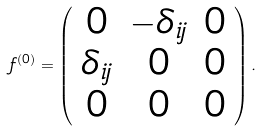Convert formula to latex. <formula><loc_0><loc_0><loc_500><loc_500>f ^ { ( 0 ) } = \left ( \begin{array} { c c c } { 0 } & { { - \delta _ { i j } } } & { 0 } \\ { { \delta _ { i j } } } & { 0 } & { 0 } \\ { 0 } & { 0 } & { 0 } \end{array} \right ) .</formula> 